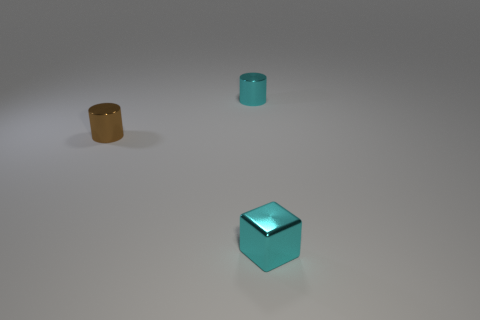Add 3 small cyan metallic cylinders. How many objects exist? 6 Subtract all cylinders. How many objects are left? 1 Subtract all small metal blocks. Subtract all cyan objects. How many objects are left? 0 Add 1 brown cylinders. How many brown cylinders are left? 2 Add 2 tiny cyan shiny objects. How many tiny cyan shiny objects exist? 4 Subtract 0 yellow balls. How many objects are left? 3 